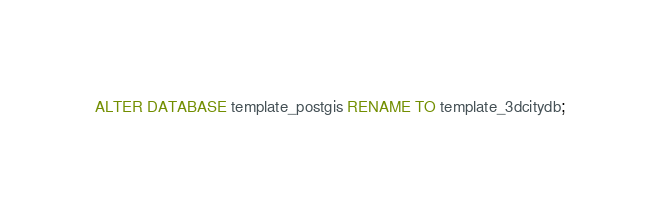Convert code to text. <code><loc_0><loc_0><loc_500><loc_500><_SQL_>ALTER DATABASE template_postgis RENAME TO template_3dcitydb;
</code> 